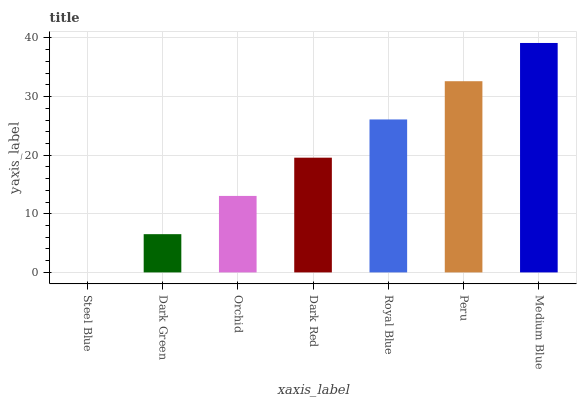Is Steel Blue the minimum?
Answer yes or no. Yes. Is Medium Blue the maximum?
Answer yes or no. Yes. Is Dark Green the minimum?
Answer yes or no. No. Is Dark Green the maximum?
Answer yes or no. No. Is Dark Green greater than Steel Blue?
Answer yes or no. Yes. Is Steel Blue less than Dark Green?
Answer yes or no. Yes. Is Steel Blue greater than Dark Green?
Answer yes or no. No. Is Dark Green less than Steel Blue?
Answer yes or no. No. Is Dark Red the high median?
Answer yes or no. Yes. Is Dark Red the low median?
Answer yes or no. Yes. Is Orchid the high median?
Answer yes or no. No. Is Dark Green the low median?
Answer yes or no. No. 